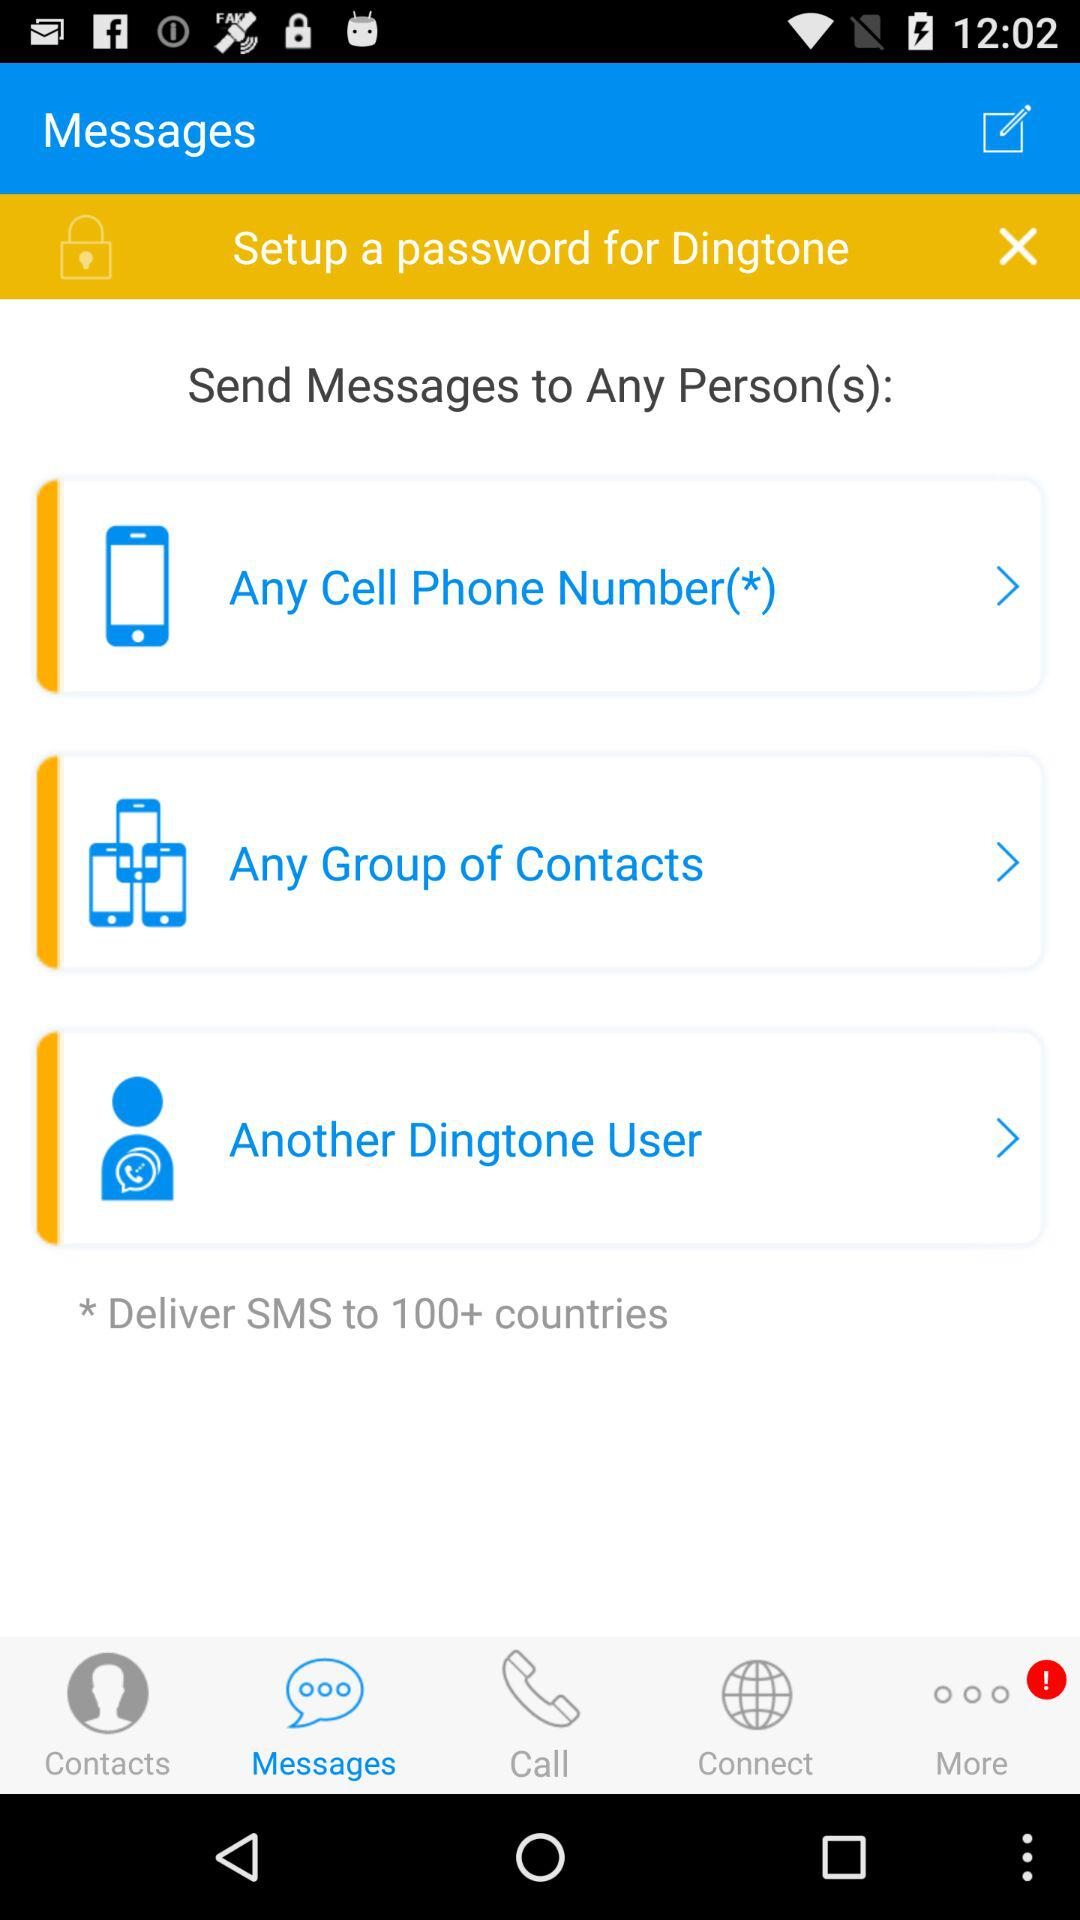How many options are there to send messages?
Answer the question using a single word or phrase. 3 